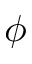<formula> <loc_0><loc_0><loc_500><loc_500>\phi</formula> 